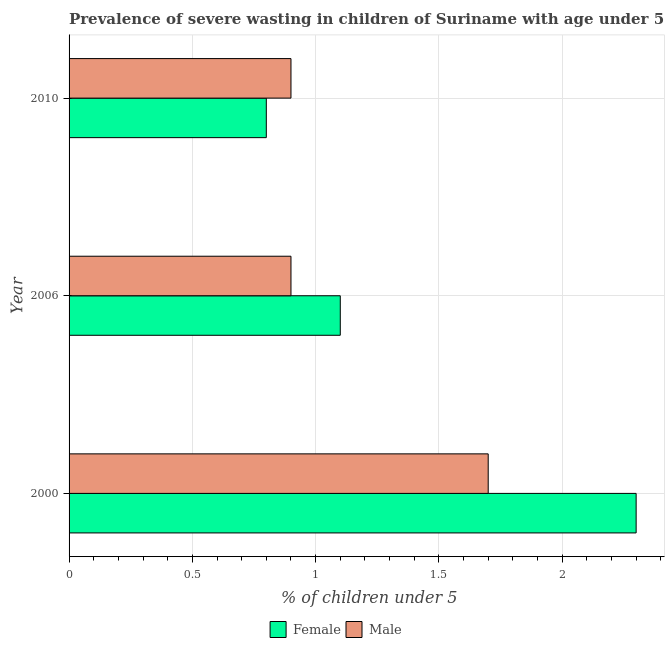How many different coloured bars are there?
Offer a terse response. 2. Are the number of bars per tick equal to the number of legend labels?
Your response must be concise. Yes. How many bars are there on the 1st tick from the bottom?
Your answer should be compact. 2. What is the label of the 2nd group of bars from the top?
Make the answer very short. 2006. What is the percentage of undernourished male children in 2006?
Give a very brief answer. 0.9. Across all years, what is the maximum percentage of undernourished female children?
Make the answer very short. 2.3. Across all years, what is the minimum percentage of undernourished female children?
Give a very brief answer. 0.8. In which year was the percentage of undernourished female children minimum?
Your answer should be compact. 2010. What is the total percentage of undernourished male children in the graph?
Give a very brief answer. 3.5. What is the difference between the percentage of undernourished female children in 2000 and the percentage of undernourished male children in 2006?
Your response must be concise. 1.4. What is the average percentage of undernourished male children per year?
Provide a succinct answer. 1.17. In how many years, is the percentage of undernourished female children greater than 1.9 %?
Ensure brevity in your answer.  1. Is the difference between the percentage of undernourished female children in 2006 and 2010 greater than the difference between the percentage of undernourished male children in 2006 and 2010?
Ensure brevity in your answer.  Yes. In how many years, is the percentage of undernourished female children greater than the average percentage of undernourished female children taken over all years?
Your response must be concise. 1. Is the sum of the percentage of undernourished male children in 2000 and 2010 greater than the maximum percentage of undernourished female children across all years?
Give a very brief answer. Yes. Are all the bars in the graph horizontal?
Provide a succinct answer. Yes. How many legend labels are there?
Keep it short and to the point. 2. How are the legend labels stacked?
Offer a very short reply. Horizontal. What is the title of the graph?
Provide a succinct answer. Prevalence of severe wasting in children of Suriname with age under 5 years. What is the label or title of the X-axis?
Provide a succinct answer.  % of children under 5. What is the label or title of the Y-axis?
Provide a short and direct response. Year. What is the  % of children under 5 of Female in 2000?
Provide a short and direct response. 2.3. What is the  % of children under 5 in Male in 2000?
Give a very brief answer. 1.7. What is the  % of children under 5 in Female in 2006?
Keep it short and to the point. 1.1. What is the  % of children under 5 in Male in 2006?
Make the answer very short. 0.9. What is the  % of children under 5 of Female in 2010?
Offer a very short reply. 0.8. What is the  % of children under 5 in Male in 2010?
Offer a very short reply. 0.9. Across all years, what is the maximum  % of children under 5 in Female?
Make the answer very short. 2.3. Across all years, what is the maximum  % of children under 5 in Male?
Provide a succinct answer. 1.7. Across all years, what is the minimum  % of children under 5 in Female?
Offer a terse response. 0.8. Across all years, what is the minimum  % of children under 5 of Male?
Provide a short and direct response. 0.9. What is the total  % of children under 5 of Female in the graph?
Your answer should be very brief. 4.2. What is the total  % of children under 5 in Male in the graph?
Your answer should be very brief. 3.5. What is the difference between the  % of children under 5 of Female in 2000 and that in 2010?
Give a very brief answer. 1.5. What is the difference between the  % of children under 5 in Male in 2000 and that in 2010?
Offer a very short reply. 0.8. What is the average  % of children under 5 in Female per year?
Your answer should be very brief. 1.4. What is the average  % of children under 5 in Male per year?
Provide a succinct answer. 1.17. In the year 2006, what is the difference between the  % of children under 5 in Female and  % of children under 5 in Male?
Make the answer very short. 0.2. In the year 2010, what is the difference between the  % of children under 5 of Female and  % of children under 5 of Male?
Your response must be concise. -0.1. What is the ratio of the  % of children under 5 in Female in 2000 to that in 2006?
Keep it short and to the point. 2.09. What is the ratio of the  % of children under 5 in Male in 2000 to that in 2006?
Your answer should be compact. 1.89. What is the ratio of the  % of children under 5 in Female in 2000 to that in 2010?
Ensure brevity in your answer.  2.88. What is the ratio of the  % of children under 5 of Male in 2000 to that in 2010?
Keep it short and to the point. 1.89. What is the ratio of the  % of children under 5 in Female in 2006 to that in 2010?
Your response must be concise. 1.38. What is the difference between the highest and the second highest  % of children under 5 of Female?
Provide a short and direct response. 1.2. What is the difference between the highest and the lowest  % of children under 5 in Male?
Ensure brevity in your answer.  0.8. 